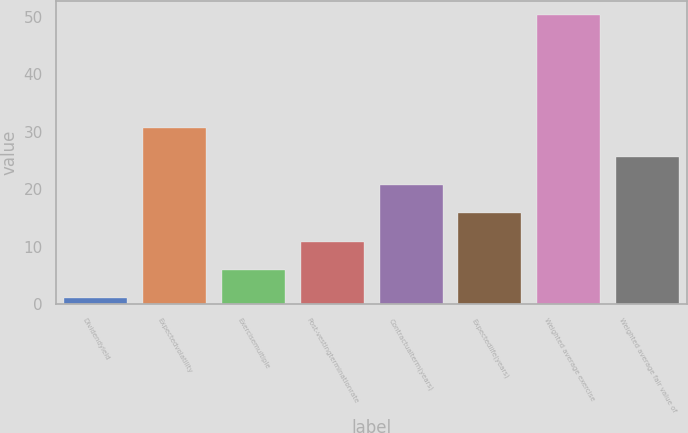<chart> <loc_0><loc_0><loc_500><loc_500><bar_chart><fcel>Dividendyield<fcel>Expectedvolatility<fcel>Exercisemultiple<fcel>Post-vestingterminationrate<fcel>Contractualterm(years)<fcel>Expectedlife(years)<fcel>Weighted average exercise<fcel>Weighted average fair value of<nl><fcel>1.04<fcel>30.56<fcel>5.96<fcel>10.88<fcel>20.72<fcel>15.8<fcel>50.21<fcel>25.64<nl></chart> 